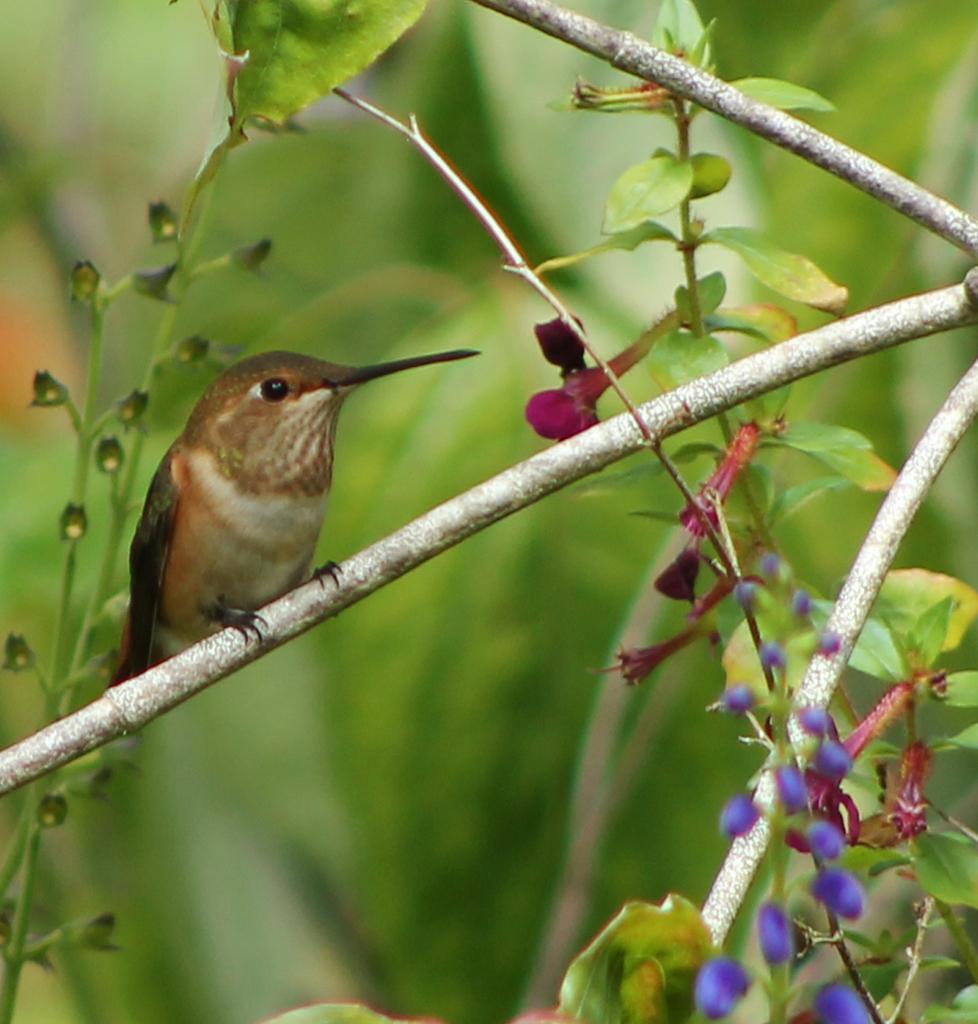Please provide a concise description of this image. In the picture I can see a bird on the plant stem. The background of the image is blurred, which is in green color. 